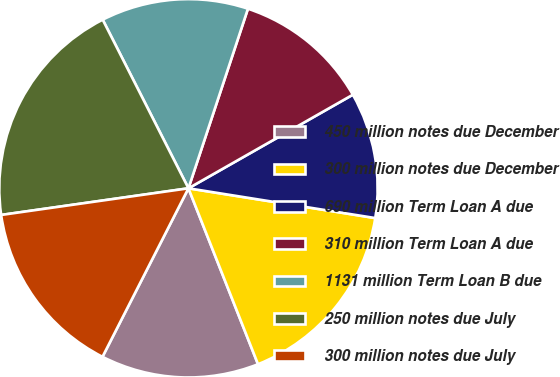Convert chart. <chart><loc_0><loc_0><loc_500><loc_500><pie_chart><fcel>450 million notes due December<fcel>300 million notes due December<fcel>690 million Term Loan A due<fcel>310 million Term Loan A due<fcel>1131 million Term Loan B due<fcel>250 million notes due July<fcel>300 million notes due July<nl><fcel>13.5%<fcel>16.49%<fcel>10.75%<fcel>11.67%<fcel>12.58%<fcel>19.76%<fcel>15.24%<nl></chart> 